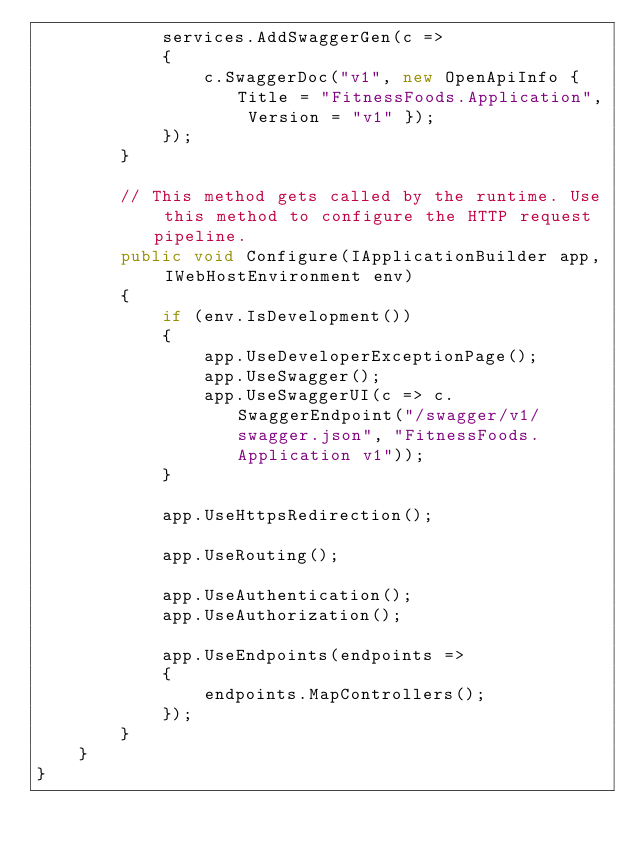<code> <loc_0><loc_0><loc_500><loc_500><_C#_>            services.AddSwaggerGen(c =>
            {
                c.SwaggerDoc("v1", new OpenApiInfo { Title = "FitnessFoods.Application", Version = "v1" });
            });
        }

        // This method gets called by the runtime. Use this method to configure the HTTP request pipeline.
        public void Configure(IApplicationBuilder app, IWebHostEnvironment env)
        {
            if (env.IsDevelopment())
            {
                app.UseDeveloperExceptionPage();
                app.UseSwagger();
                app.UseSwaggerUI(c => c.SwaggerEndpoint("/swagger/v1/swagger.json", "FitnessFoods.Application v1"));
            }

            app.UseHttpsRedirection();

            app.UseRouting();

            app.UseAuthentication();
            app.UseAuthorization();

            app.UseEndpoints(endpoints =>
            {
                endpoints.MapControllers();
            });
        }
    }
}
</code> 